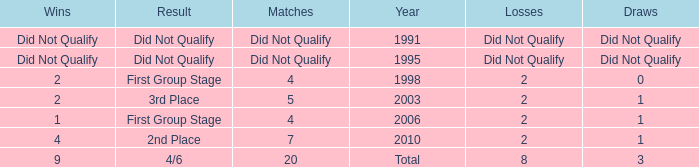What were the matches where the teams finished in the first group stage, in 1998? 4.0. 